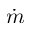Convert formula to latex. <formula><loc_0><loc_0><loc_500><loc_500>\dot { m }</formula> 